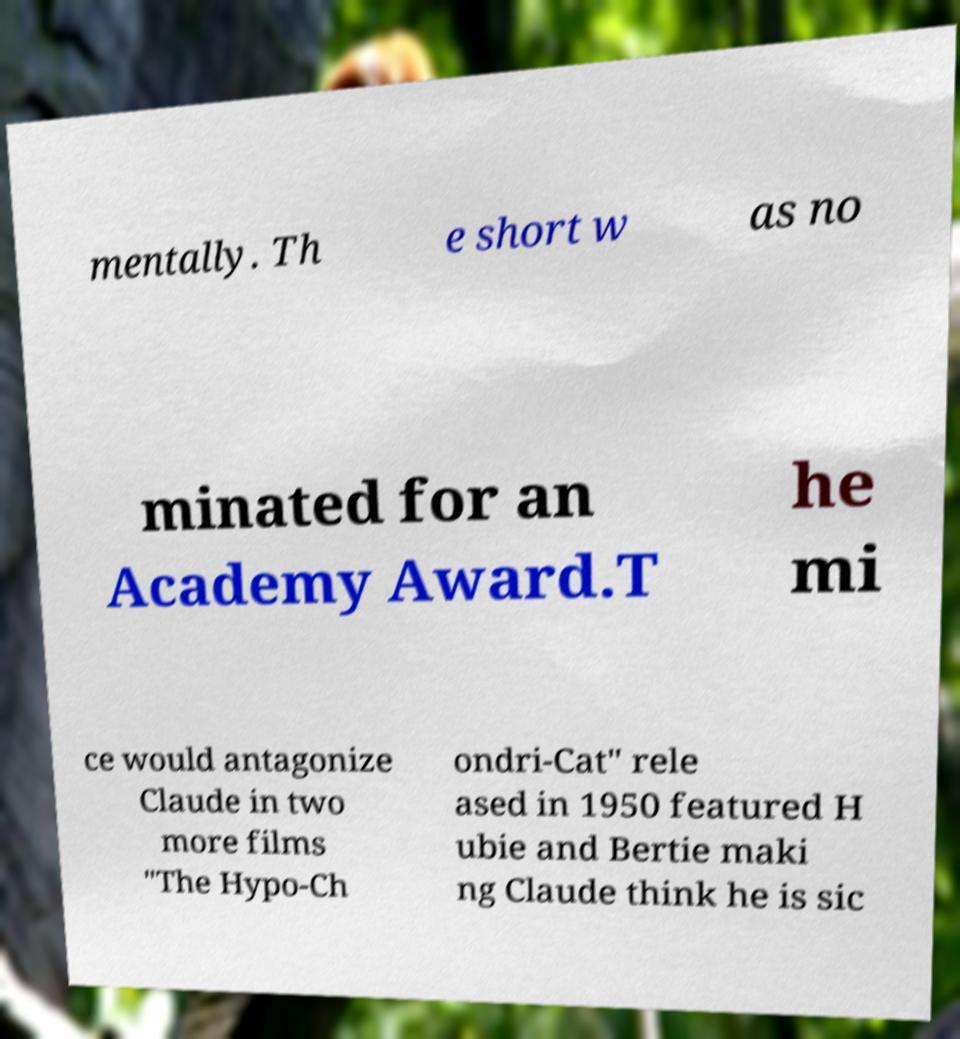For documentation purposes, I need the text within this image transcribed. Could you provide that? mentally. Th e short w as no minated for an Academy Award.T he mi ce would antagonize Claude in two more films "The Hypo-Ch ondri-Cat" rele ased in 1950 featured H ubie and Bertie maki ng Claude think he is sic 